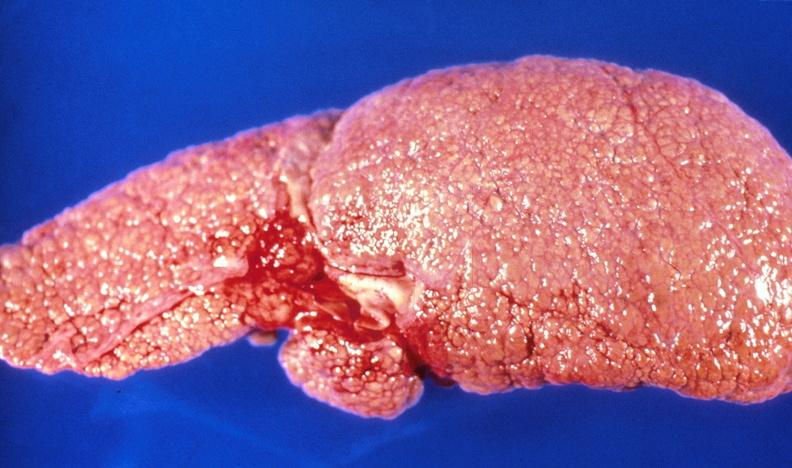s supernumerary digit present?
Answer the question using a single word or phrase. No 